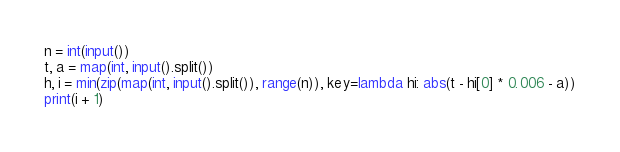Convert code to text. <code><loc_0><loc_0><loc_500><loc_500><_Python_>n = int(input())
t, a = map(int, input().split())
h, i = min(zip(map(int, input().split()), range(n)), key=lambda hi: abs(t - hi[0] * 0.006 - a))
print(i + 1)
</code> 